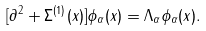Convert formula to latex. <formula><loc_0><loc_0><loc_500><loc_500>[ \partial ^ { 2 } + \Sigma ^ { ( 1 ) } ( x ) ] \phi _ { \alpha } ( x ) = \Lambda _ { \alpha } \phi _ { \alpha } ( x ) .</formula> 